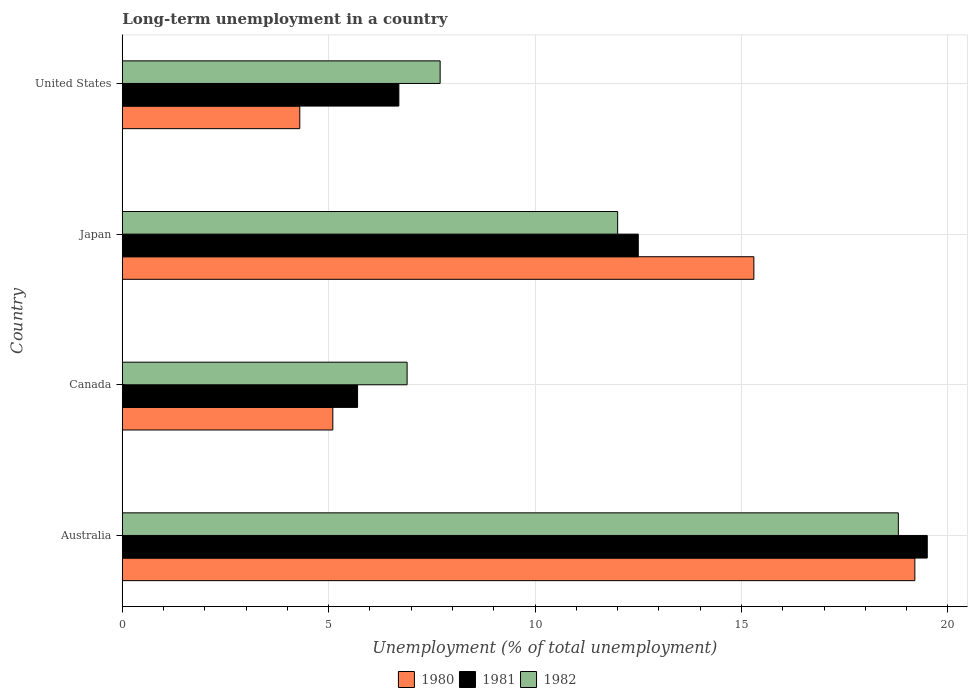How many different coloured bars are there?
Your response must be concise. 3. Are the number of bars per tick equal to the number of legend labels?
Give a very brief answer. Yes. Are the number of bars on each tick of the Y-axis equal?
Ensure brevity in your answer.  Yes. How many bars are there on the 2nd tick from the bottom?
Your answer should be compact. 3. In how many cases, is the number of bars for a given country not equal to the number of legend labels?
Keep it short and to the point. 0. What is the percentage of long-term unemployed population in 1982 in Australia?
Offer a terse response. 18.8. Across all countries, what is the maximum percentage of long-term unemployed population in 1980?
Your answer should be very brief. 19.2. Across all countries, what is the minimum percentage of long-term unemployed population in 1982?
Provide a short and direct response. 6.9. In which country was the percentage of long-term unemployed population in 1981 maximum?
Offer a very short reply. Australia. In which country was the percentage of long-term unemployed population in 1981 minimum?
Provide a short and direct response. Canada. What is the total percentage of long-term unemployed population in 1982 in the graph?
Make the answer very short. 45.4. What is the difference between the percentage of long-term unemployed population in 1981 in Japan and that in United States?
Your answer should be compact. 5.8. What is the difference between the percentage of long-term unemployed population in 1982 in Japan and the percentage of long-term unemployed population in 1980 in Canada?
Provide a succinct answer. 6.9. What is the average percentage of long-term unemployed population in 1980 per country?
Keep it short and to the point. 10.98. What is the difference between the percentage of long-term unemployed population in 1981 and percentage of long-term unemployed population in 1982 in Australia?
Ensure brevity in your answer.  0.7. What is the ratio of the percentage of long-term unemployed population in 1982 in Australia to that in United States?
Your answer should be compact. 2.44. Is the difference between the percentage of long-term unemployed population in 1981 in Australia and United States greater than the difference between the percentage of long-term unemployed population in 1982 in Australia and United States?
Offer a very short reply. Yes. What is the difference between the highest and the second highest percentage of long-term unemployed population in 1980?
Your answer should be very brief. 3.9. What is the difference between the highest and the lowest percentage of long-term unemployed population in 1982?
Provide a short and direct response. 11.9. In how many countries, is the percentage of long-term unemployed population in 1981 greater than the average percentage of long-term unemployed population in 1981 taken over all countries?
Offer a terse response. 2. Is it the case that in every country, the sum of the percentage of long-term unemployed population in 1982 and percentage of long-term unemployed population in 1980 is greater than the percentage of long-term unemployed population in 1981?
Provide a short and direct response. Yes. How many bars are there?
Offer a very short reply. 12. Are all the bars in the graph horizontal?
Offer a terse response. Yes. What is the difference between two consecutive major ticks on the X-axis?
Make the answer very short. 5. Does the graph contain any zero values?
Offer a very short reply. No. How many legend labels are there?
Offer a terse response. 3. How are the legend labels stacked?
Your answer should be very brief. Horizontal. What is the title of the graph?
Provide a short and direct response. Long-term unemployment in a country. What is the label or title of the X-axis?
Offer a very short reply. Unemployment (% of total unemployment). What is the label or title of the Y-axis?
Your answer should be very brief. Country. What is the Unemployment (% of total unemployment) in 1980 in Australia?
Keep it short and to the point. 19.2. What is the Unemployment (% of total unemployment) of 1982 in Australia?
Your response must be concise. 18.8. What is the Unemployment (% of total unemployment) of 1980 in Canada?
Provide a succinct answer. 5.1. What is the Unemployment (% of total unemployment) in 1981 in Canada?
Make the answer very short. 5.7. What is the Unemployment (% of total unemployment) of 1982 in Canada?
Make the answer very short. 6.9. What is the Unemployment (% of total unemployment) in 1980 in Japan?
Provide a succinct answer. 15.3. What is the Unemployment (% of total unemployment) of 1980 in United States?
Your answer should be compact. 4.3. What is the Unemployment (% of total unemployment) in 1981 in United States?
Ensure brevity in your answer.  6.7. What is the Unemployment (% of total unemployment) of 1982 in United States?
Ensure brevity in your answer.  7.7. Across all countries, what is the maximum Unemployment (% of total unemployment) in 1980?
Your response must be concise. 19.2. Across all countries, what is the maximum Unemployment (% of total unemployment) in 1982?
Provide a succinct answer. 18.8. Across all countries, what is the minimum Unemployment (% of total unemployment) in 1980?
Ensure brevity in your answer.  4.3. Across all countries, what is the minimum Unemployment (% of total unemployment) of 1981?
Provide a succinct answer. 5.7. Across all countries, what is the minimum Unemployment (% of total unemployment) in 1982?
Keep it short and to the point. 6.9. What is the total Unemployment (% of total unemployment) in 1980 in the graph?
Your answer should be very brief. 43.9. What is the total Unemployment (% of total unemployment) in 1981 in the graph?
Make the answer very short. 44.4. What is the total Unemployment (% of total unemployment) of 1982 in the graph?
Ensure brevity in your answer.  45.4. What is the difference between the Unemployment (% of total unemployment) of 1982 in Australia and that in Canada?
Your answer should be very brief. 11.9. What is the difference between the Unemployment (% of total unemployment) of 1980 in Australia and that in Japan?
Your answer should be compact. 3.9. What is the difference between the Unemployment (% of total unemployment) of 1981 in Australia and that in Japan?
Keep it short and to the point. 7. What is the difference between the Unemployment (% of total unemployment) of 1982 in Australia and that in Japan?
Make the answer very short. 6.8. What is the difference between the Unemployment (% of total unemployment) in 1980 in Australia and that in United States?
Provide a short and direct response. 14.9. What is the difference between the Unemployment (% of total unemployment) of 1981 in Australia and that in United States?
Your answer should be compact. 12.8. What is the difference between the Unemployment (% of total unemployment) in 1980 in Canada and that in Japan?
Provide a short and direct response. -10.2. What is the difference between the Unemployment (% of total unemployment) of 1980 in Canada and that in United States?
Provide a short and direct response. 0.8. What is the difference between the Unemployment (% of total unemployment) of 1981 in Canada and that in United States?
Your answer should be very brief. -1. What is the difference between the Unemployment (% of total unemployment) in 1982 in Canada and that in United States?
Offer a terse response. -0.8. What is the difference between the Unemployment (% of total unemployment) of 1980 in Japan and that in United States?
Ensure brevity in your answer.  11. What is the difference between the Unemployment (% of total unemployment) in 1981 in Japan and that in United States?
Make the answer very short. 5.8. What is the difference between the Unemployment (% of total unemployment) of 1982 in Japan and that in United States?
Give a very brief answer. 4.3. What is the difference between the Unemployment (% of total unemployment) of 1980 in Australia and the Unemployment (% of total unemployment) of 1981 in Canada?
Keep it short and to the point. 13.5. What is the difference between the Unemployment (% of total unemployment) of 1980 in Australia and the Unemployment (% of total unemployment) of 1982 in Canada?
Make the answer very short. 12.3. What is the difference between the Unemployment (% of total unemployment) of 1980 in Australia and the Unemployment (% of total unemployment) of 1981 in Japan?
Keep it short and to the point. 6.7. What is the difference between the Unemployment (% of total unemployment) of 1981 in Australia and the Unemployment (% of total unemployment) of 1982 in United States?
Your answer should be very brief. 11.8. What is the difference between the Unemployment (% of total unemployment) in 1980 in Canada and the Unemployment (% of total unemployment) in 1981 in United States?
Provide a succinct answer. -1.6. What is the difference between the Unemployment (% of total unemployment) of 1980 in Canada and the Unemployment (% of total unemployment) of 1982 in United States?
Give a very brief answer. -2.6. What is the difference between the Unemployment (% of total unemployment) of 1981 in Canada and the Unemployment (% of total unemployment) of 1982 in United States?
Offer a very short reply. -2. What is the difference between the Unemployment (% of total unemployment) in 1980 in Japan and the Unemployment (% of total unemployment) in 1981 in United States?
Offer a terse response. 8.6. What is the difference between the Unemployment (% of total unemployment) of 1980 in Japan and the Unemployment (% of total unemployment) of 1982 in United States?
Your answer should be compact. 7.6. What is the average Unemployment (% of total unemployment) in 1980 per country?
Provide a succinct answer. 10.97. What is the average Unemployment (% of total unemployment) in 1982 per country?
Your answer should be compact. 11.35. What is the difference between the Unemployment (% of total unemployment) of 1980 and Unemployment (% of total unemployment) of 1981 in Canada?
Your answer should be compact. -0.6. What is the difference between the Unemployment (% of total unemployment) of 1980 and Unemployment (% of total unemployment) of 1982 in Canada?
Your answer should be compact. -1.8. What is the difference between the Unemployment (% of total unemployment) of 1981 and Unemployment (% of total unemployment) of 1982 in Canada?
Provide a short and direct response. -1.2. What is the difference between the Unemployment (% of total unemployment) of 1980 and Unemployment (% of total unemployment) of 1982 in United States?
Provide a short and direct response. -3.4. What is the difference between the Unemployment (% of total unemployment) of 1981 and Unemployment (% of total unemployment) of 1982 in United States?
Provide a succinct answer. -1. What is the ratio of the Unemployment (% of total unemployment) in 1980 in Australia to that in Canada?
Give a very brief answer. 3.76. What is the ratio of the Unemployment (% of total unemployment) in 1981 in Australia to that in Canada?
Provide a short and direct response. 3.42. What is the ratio of the Unemployment (% of total unemployment) in 1982 in Australia to that in Canada?
Provide a short and direct response. 2.72. What is the ratio of the Unemployment (% of total unemployment) of 1980 in Australia to that in Japan?
Your answer should be compact. 1.25. What is the ratio of the Unemployment (% of total unemployment) of 1981 in Australia to that in Japan?
Provide a succinct answer. 1.56. What is the ratio of the Unemployment (% of total unemployment) of 1982 in Australia to that in Japan?
Provide a succinct answer. 1.57. What is the ratio of the Unemployment (% of total unemployment) in 1980 in Australia to that in United States?
Ensure brevity in your answer.  4.47. What is the ratio of the Unemployment (% of total unemployment) of 1981 in Australia to that in United States?
Your answer should be very brief. 2.91. What is the ratio of the Unemployment (% of total unemployment) of 1982 in Australia to that in United States?
Provide a succinct answer. 2.44. What is the ratio of the Unemployment (% of total unemployment) in 1981 in Canada to that in Japan?
Your response must be concise. 0.46. What is the ratio of the Unemployment (% of total unemployment) in 1982 in Canada to that in Japan?
Your answer should be very brief. 0.57. What is the ratio of the Unemployment (% of total unemployment) in 1980 in Canada to that in United States?
Provide a succinct answer. 1.19. What is the ratio of the Unemployment (% of total unemployment) in 1981 in Canada to that in United States?
Provide a short and direct response. 0.85. What is the ratio of the Unemployment (% of total unemployment) of 1982 in Canada to that in United States?
Your response must be concise. 0.9. What is the ratio of the Unemployment (% of total unemployment) in 1980 in Japan to that in United States?
Ensure brevity in your answer.  3.56. What is the ratio of the Unemployment (% of total unemployment) in 1981 in Japan to that in United States?
Ensure brevity in your answer.  1.87. What is the ratio of the Unemployment (% of total unemployment) in 1982 in Japan to that in United States?
Give a very brief answer. 1.56. What is the difference between the highest and the second highest Unemployment (% of total unemployment) of 1982?
Your response must be concise. 6.8. What is the difference between the highest and the lowest Unemployment (% of total unemployment) in 1980?
Your response must be concise. 14.9. 